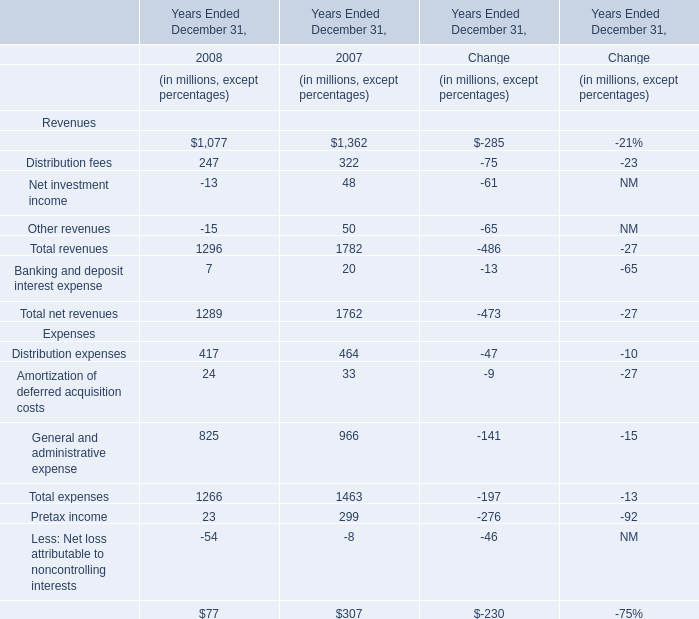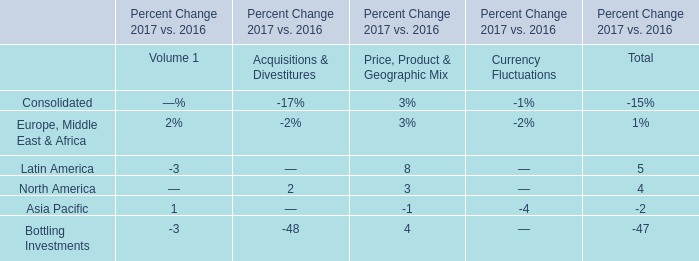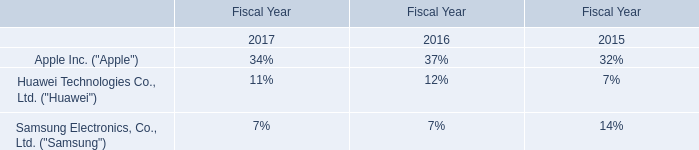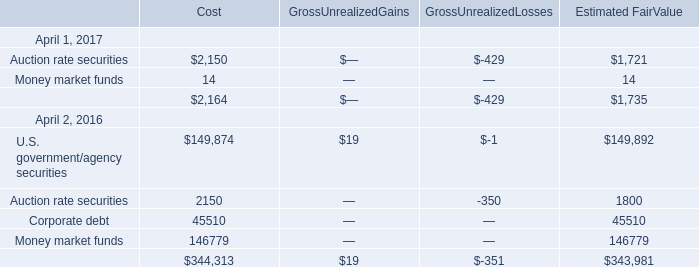IfTotal net revenues develops with the same increasing rate in 2008, what will it reach in 2009？ (in million) 
Computations: ((1 + ((1289 - 1762) / 1762)) * 1289)
Answer: 942.97446. 